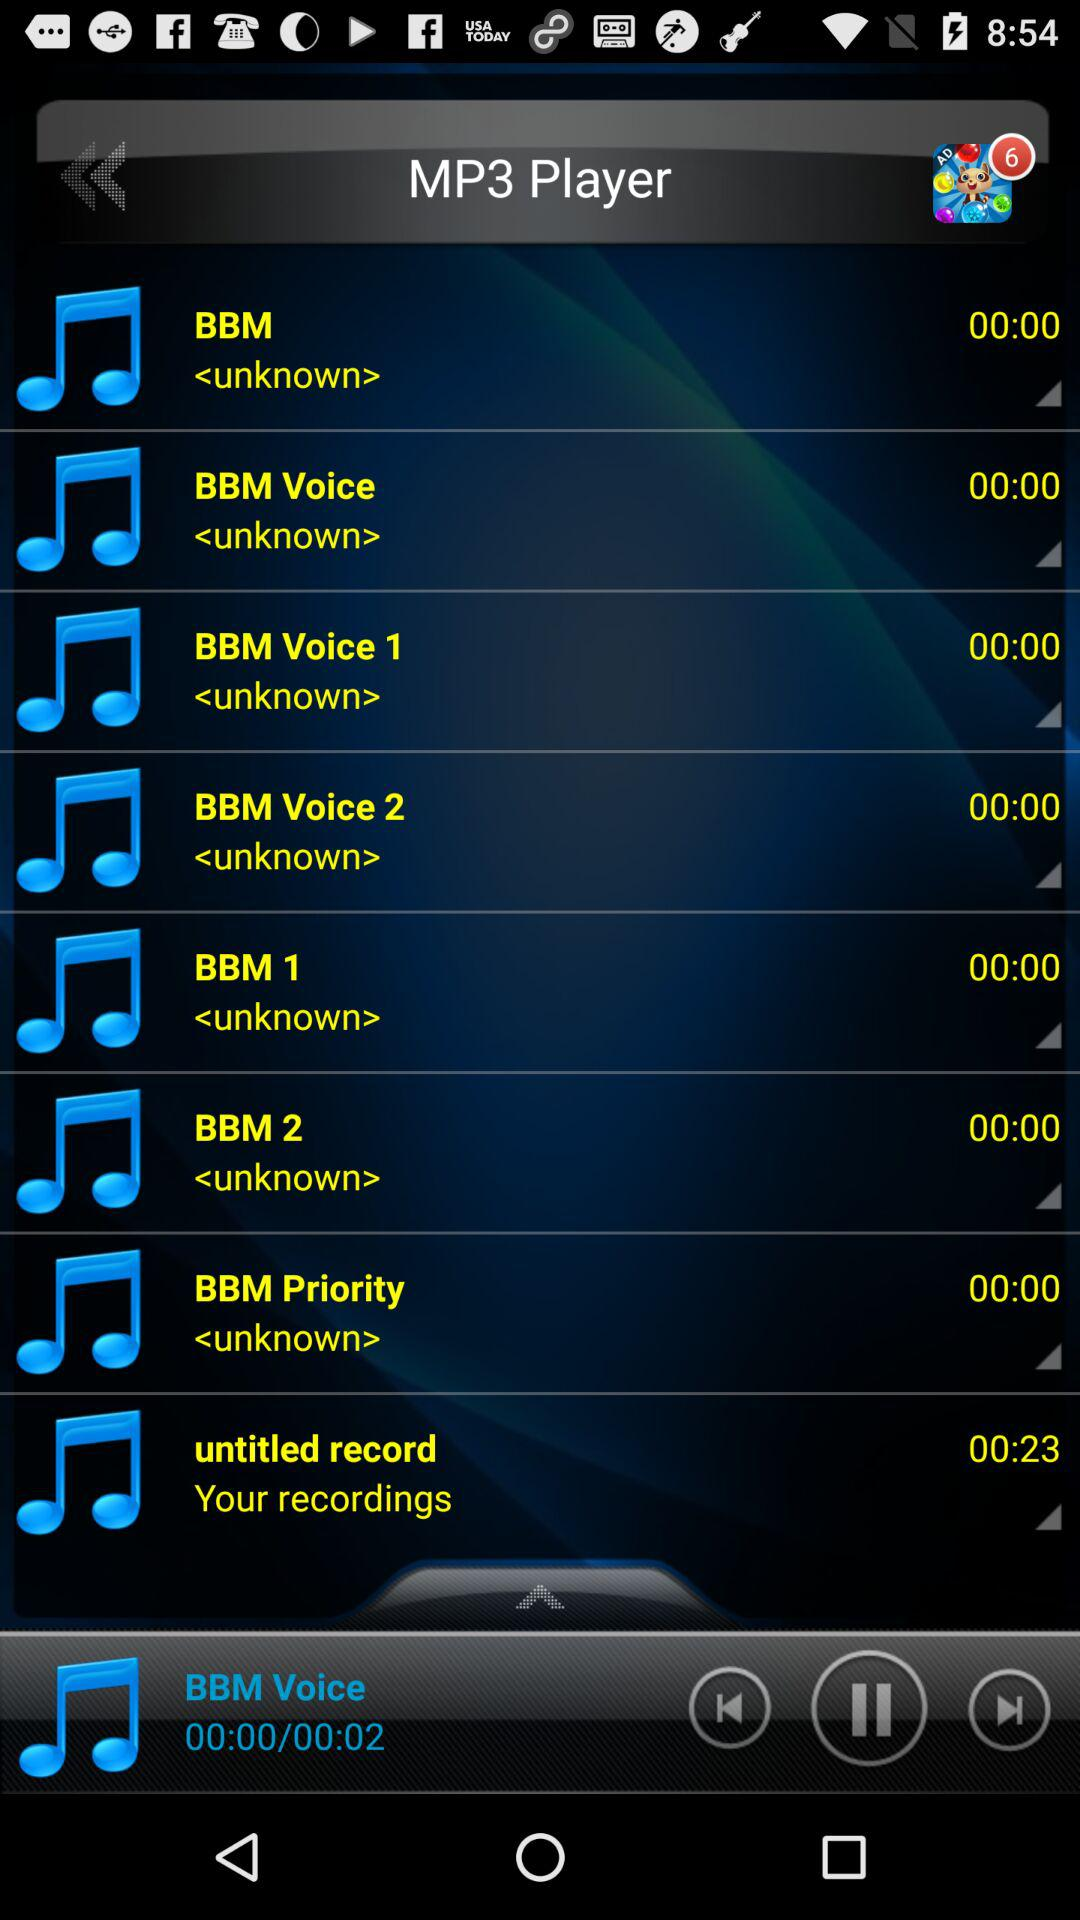What is the duration of the audio "BBM"? The duration of the audio "BBM" is 00:00. 